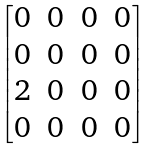<formula> <loc_0><loc_0><loc_500><loc_500>\begin{bmatrix} 0 & 0 & 0 & 0 \\ 0 & 0 & 0 & 0 \\ 2 & 0 & 0 & 0 \\ 0 & 0 & 0 & 0 \end{bmatrix}</formula> 